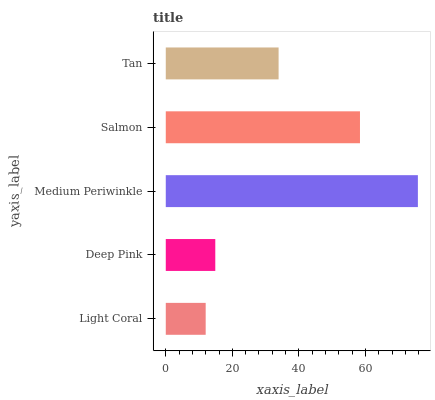Is Light Coral the minimum?
Answer yes or no. Yes. Is Medium Periwinkle the maximum?
Answer yes or no. Yes. Is Deep Pink the minimum?
Answer yes or no. No. Is Deep Pink the maximum?
Answer yes or no. No. Is Deep Pink greater than Light Coral?
Answer yes or no. Yes. Is Light Coral less than Deep Pink?
Answer yes or no. Yes. Is Light Coral greater than Deep Pink?
Answer yes or no. No. Is Deep Pink less than Light Coral?
Answer yes or no. No. Is Tan the high median?
Answer yes or no. Yes. Is Tan the low median?
Answer yes or no. Yes. Is Deep Pink the high median?
Answer yes or no. No. Is Deep Pink the low median?
Answer yes or no. No. 